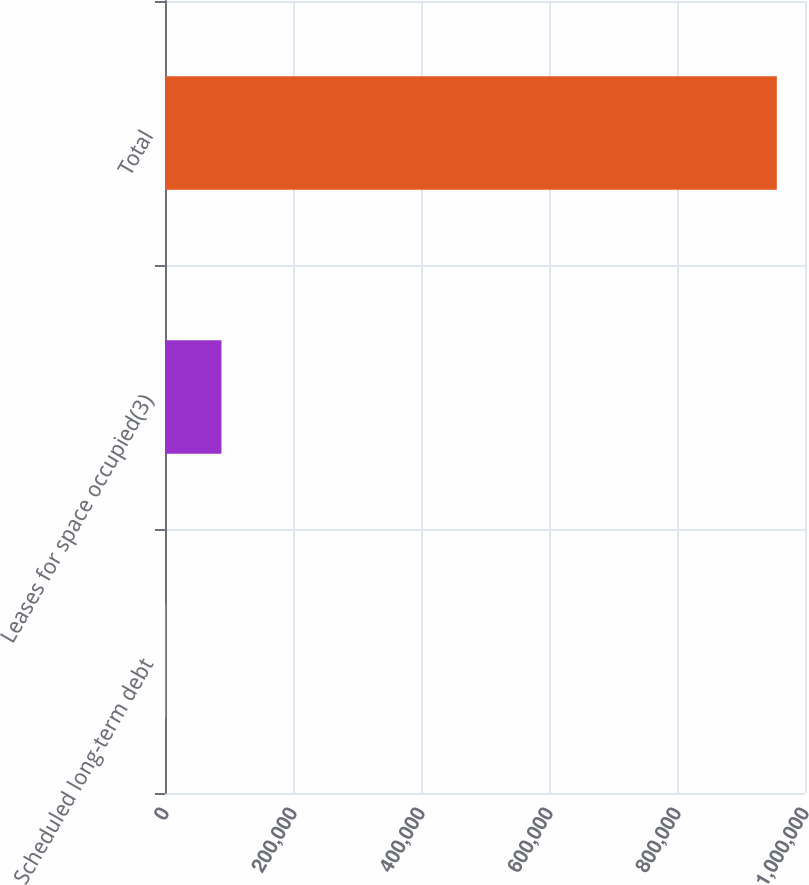<chart> <loc_0><loc_0><loc_500><loc_500><bar_chart><fcel>Scheduled long-term debt<fcel>Leases for space occupied(3)<fcel>Total<nl><fcel>868<fcel>88215.4<fcel>955962<nl></chart> 